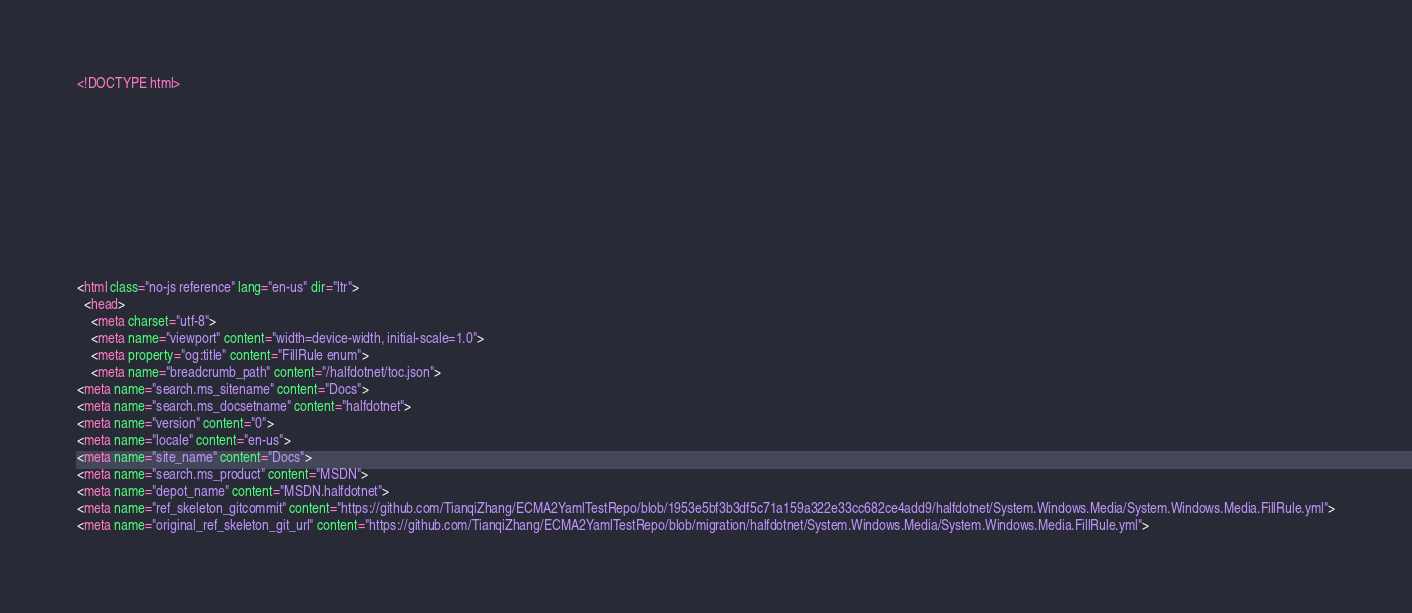Convert code to text. <code><loc_0><loc_0><loc_500><loc_500><_HTML_><!DOCTYPE html>



  


  


  

<html class="no-js reference" lang="en-us" dir="ltr">
  <head>
    <meta charset="utf-8">
    <meta name="viewport" content="width=device-width, initial-scale=1.0">
    <meta property="og:title" content="FillRule enum">
    <meta name="breadcrumb_path" content="/halfdotnet/toc.json">
<meta name="search.ms_sitename" content="Docs">
<meta name="search.ms_docsetname" content="halfdotnet">
<meta name="version" content="0">
<meta name="locale" content="en-us">
<meta name="site_name" content="Docs">
<meta name="search.ms_product" content="MSDN">
<meta name="depot_name" content="MSDN.halfdotnet">
<meta name="ref_skeleton_gitcommit" content="https://github.com/TianqiZhang/ECMA2YamlTestRepo/blob/1953e5bf3b3df5c71a159a322e33cc682ce4add9/halfdotnet/System.Windows.Media/System.Windows.Media.FillRule.yml">
<meta name="original_ref_skeleton_git_url" content="https://github.com/TianqiZhang/ECMA2YamlTestRepo/blob/migration/halfdotnet/System.Windows.Media/System.Windows.Media.FillRule.yml"></code> 